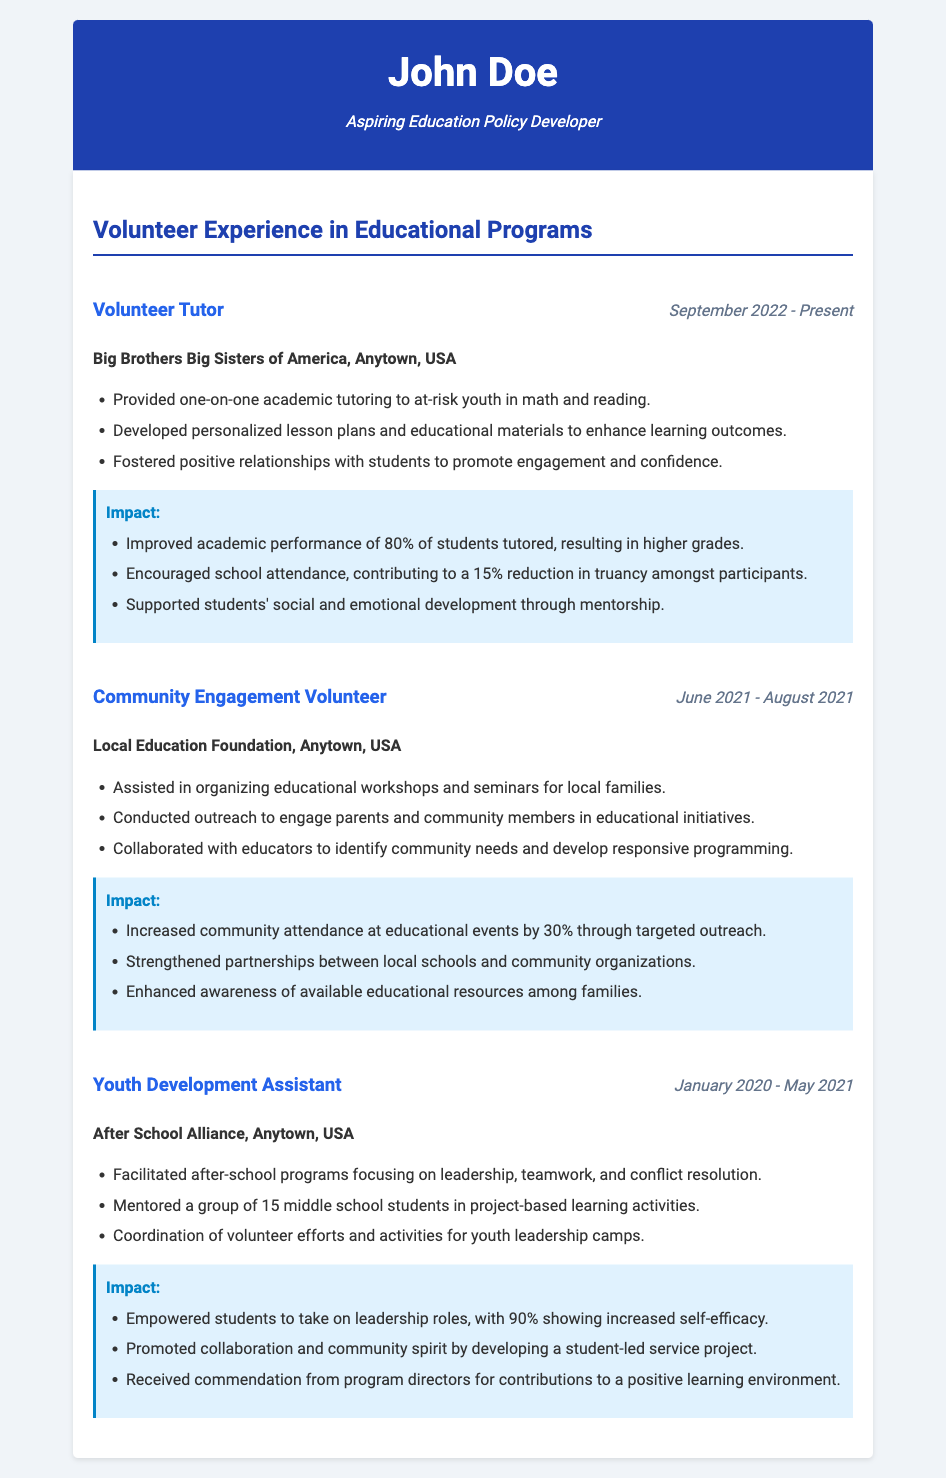What is the name of the volunteer organization where John Doe tutored? The organization where John Doe tutored is mentioned in the document under the role of Volunteer Tutor.
Answer: Big Brothers Big Sisters of America How long has John Doe been volunteering as a tutor? The duration of John Doe's volunteering as a tutor is specified in the dates section of that experience.
Answer: September 2022 - Present What percentage of students improved academically due to tutoring? This information is provided in the impact section of the Volunteer Tutor experience.
Answer: 80% When did John Doe serve as a Community Engagement Volunteer? The dates for the Community Engagement Volunteer experience are listed in the document.
Answer: June 2021 - August 2021 How many middle school students did John Doe mentor as a Youth Development Assistant? The number of students mentored is specified in the Youth Development Assistant role description.
Answer: 15 What was a key impact of the outreach conducted by John Doe? The impact of the outreach can be found in the Community Engagement Volunteer section.
Answer: Increased community attendance by 30% What type of programming did John Doe facilitate as a Youth Development Assistant? The document describes the programming focus within the Youth Development Assistant experience.
Answer: Leadership, teamwork, and conflict resolution What recognition did John Doe receive for his contributions in youth development? The recognition awarded is stated in the impact section of the Youth Development Assistant experience.
Answer: Commendation from program directors 